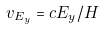Convert formula to latex. <formula><loc_0><loc_0><loc_500><loc_500>v _ { E _ { y } } = c E _ { y } / H</formula> 